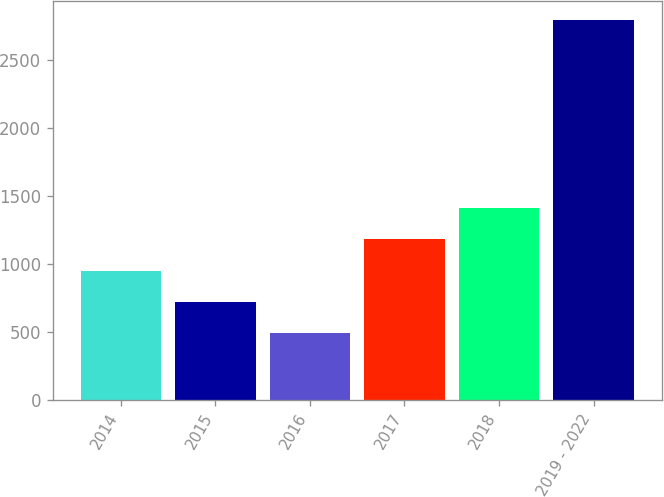Convert chart. <chart><loc_0><loc_0><loc_500><loc_500><bar_chart><fcel>2014<fcel>2015<fcel>2016<fcel>2017<fcel>2018<fcel>2019 - 2022<nl><fcel>948.4<fcel>717.7<fcel>487<fcel>1179.1<fcel>1409.8<fcel>2794<nl></chart> 